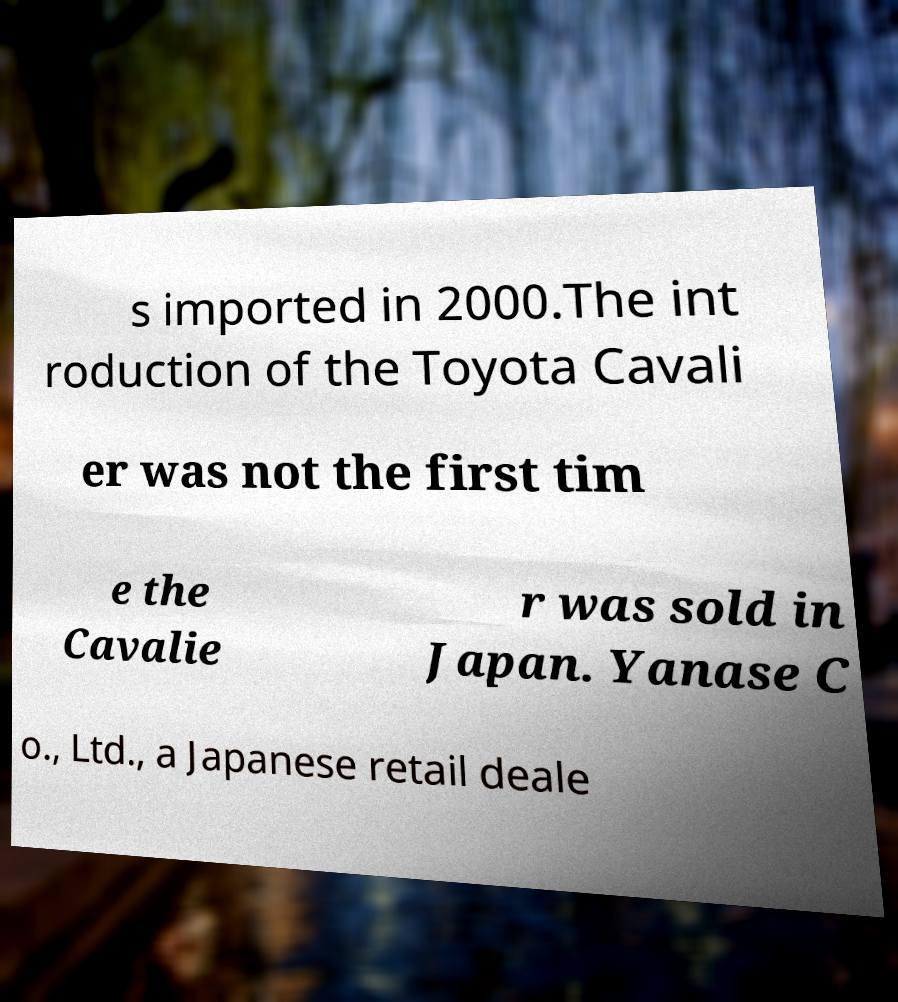What messages or text are displayed in this image? I need them in a readable, typed format. s imported in 2000.The int roduction of the Toyota Cavali er was not the first tim e the Cavalie r was sold in Japan. Yanase C o., Ltd., a Japanese retail deale 